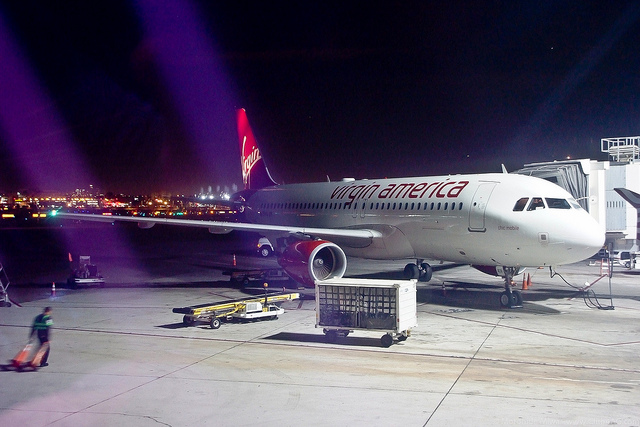Please extract the text content from this image. Virgin america 